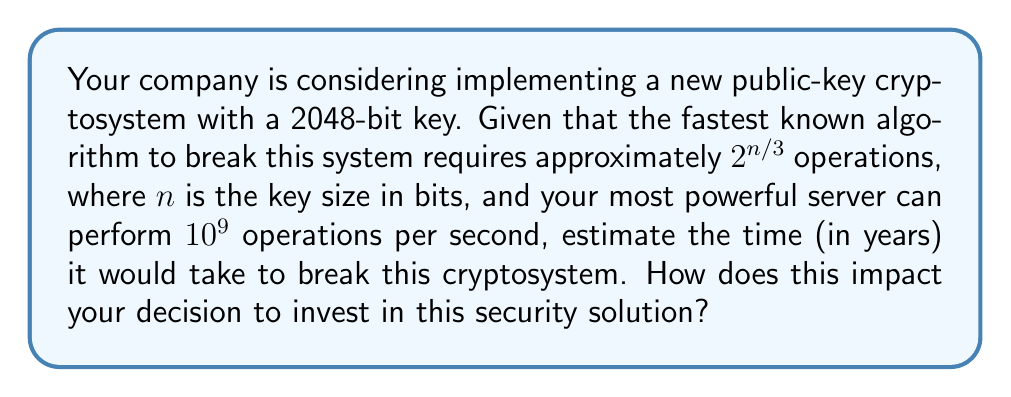Give your solution to this math problem. 1. Identify the key size: $n = 2048$ bits

2. Calculate the number of operations required:
   $$\text{Operations} = 2^{n/3} = 2^{2048/3} \approx 2^{682.67} \approx 10^{205.5}$$

3. Convert server performance to operations per year:
   $$\text{Operations per year} = 10^9 \text{ ops/sec} \times 60 \text{ sec/min} \times 60 \text{ min/hour} \times 24 \text{ hours/day} \times 365 \text{ days/year}$$
   $$\text{Operations per year} \approx 3.1536 \times 10^{16}$$

4. Calculate the time required in years:
   $$\text{Time (years)} = \frac{10^{205.5}}{3.1536 \times 10^{16}} \approx 3.17 \times 10^{188}$$

5. Interpret the result:
   This time frame is vastly longer than the age of the universe (approximately $13.8 \times 10^9$ years). The cryptosystem is computationally infeasible to break with current technology.

6. Business impact:
   The extremely long time required to break this cryptosystem suggests that it provides a very high level of security. This makes it a strong investment for protecting sensitive business data. However, the decision should also consider factors such as implementation costs, compatibility with existing systems, and potential future advancements in cryptanalysis or quantum computing that might affect its long-term security.
Answer: $3.17 \times 10^{188}$ years 